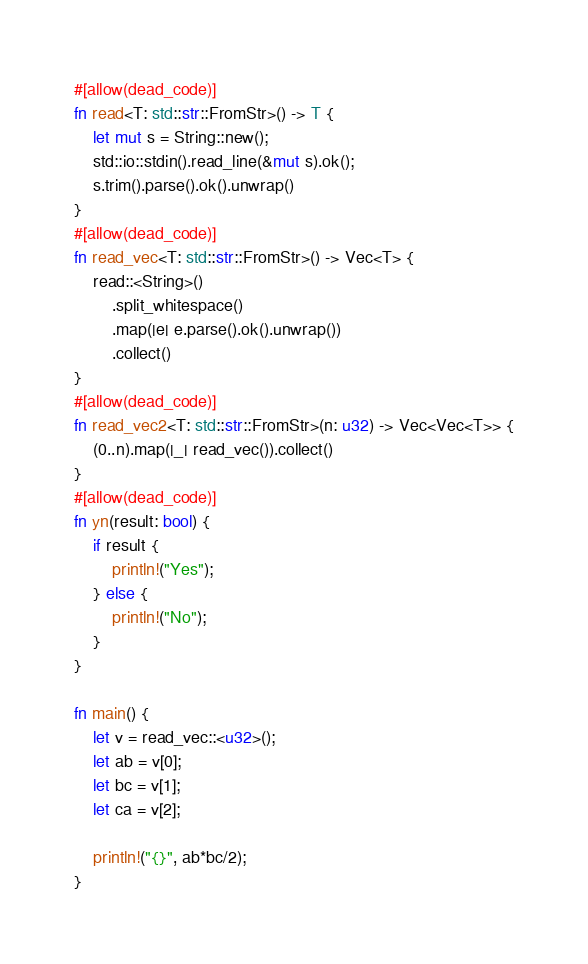<code> <loc_0><loc_0><loc_500><loc_500><_Rust_>#[allow(dead_code)]
fn read<T: std::str::FromStr>() -> T {
    let mut s = String::new();
    std::io::stdin().read_line(&mut s).ok();
    s.trim().parse().ok().unwrap()
}
#[allow(dead_code)]
fn read_vec<T: std::str::FromStr>() -> Vec<T> {
    read::<String>()
        .split_whitespace()
        .map(|e| e.parse().ok().unwrap())
        .collect()
}
#[allow(dead_code)]
fn read_vec2<T: std::str::FromStr>(n: u32) -> Vec<Vec<T>> {
    (0..n).map(|_| read_vec()).collect()
}
#[allow(dead_code)]
fn yn(result: bool) {
    if result {
        println!("Yes");
    } else {
        println!("No");
    }
}

fn main() {
    let v = read_vec::<u32>();
    let ab = v[0];
    let bc = v[1];
    let ca = v[2];

    println!("{}", ab*bc/2);
}
</code> 